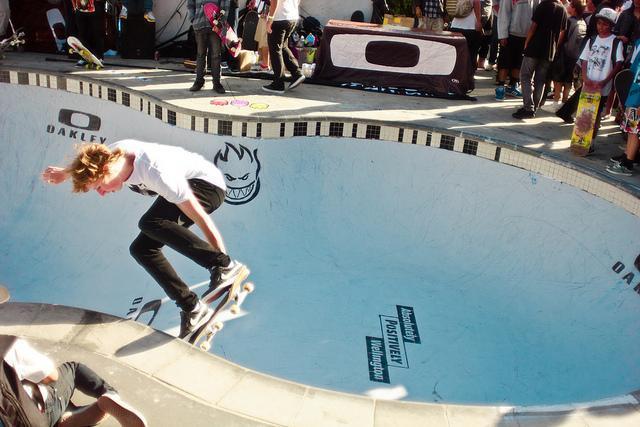How many people can be seen?
Give a very brief answer. 9. How many cars are on the left of the person?
Give a very brief answer. 0. 